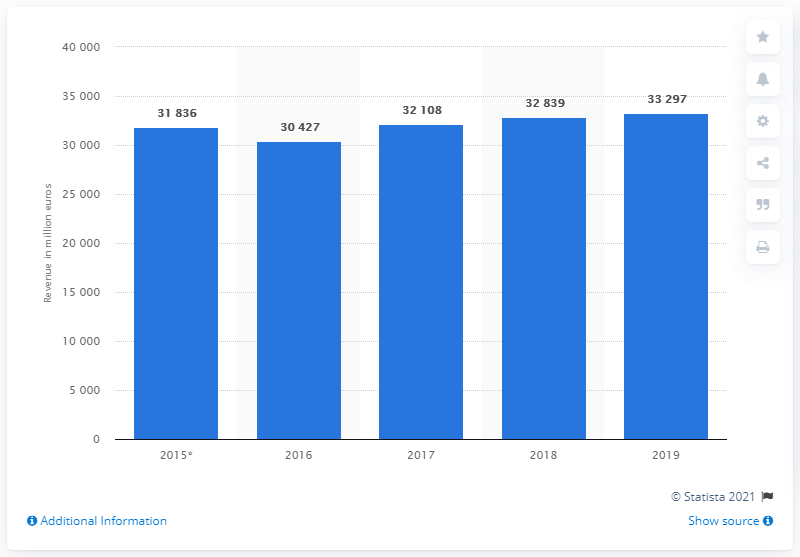Indicate a few pertinent items in this graphic. In 2019, the revenue of Credit Agricole was 33,297. 